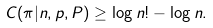<formula> <loc_0><loc_0><loc_500><loc_500>C ( \pi | n , p , P ) \geq \log n ! - \log n .</formula> 